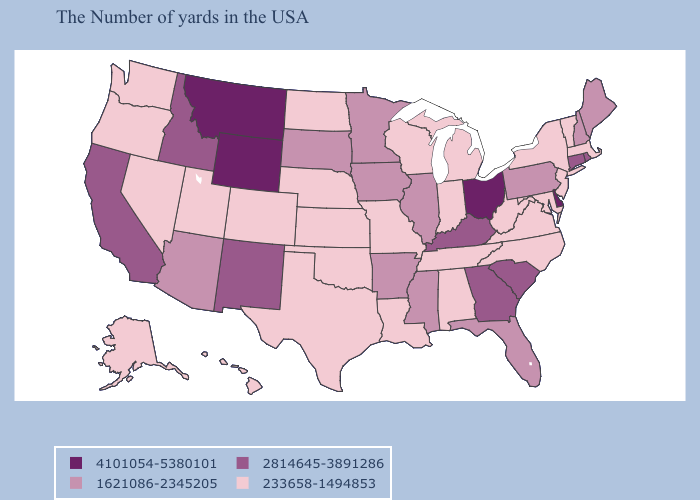Does the map have missing data?
Write a very short answer. No. Does Virginia have the highest value in the South?
Give a very brief answer. No. What is the value of Indiana?
Keep it brief. 233658-1494853. Which states hav the highest value in the Northeast?
Answer briefly. Rhode Island, Connecticut. What is the highest value in the MidWest ?
Be succinct. 4101054-5380101. Name the states that have a value in the range 233658-1494853?
Be succinct. Massachusetts, Vermont, New York, New Jersey, Maryland, Virginia, North Carolina, West Virginia, Michigan, Indiana, Alabama, Tennessee, Wisconsin, Louisiana, Missouri, Kansas, Nebraska, Oklahoma, Texas, North Dakota, Colorado, Utah, Nevada, Washington, Oregon, Alaska, Hawaii. Does the map have missing data?
Short answer required. No. Is the legend a continuous bar?
Answer briefly. No. What is the value of Utah?
Write a very short answer. 233658-1494853. Name the states that have a value in the range 1621086-2345205?
Give a very brief answer. Maine, New Hampshire, Pennsylvania, Florida, Illinois, Mississippi, Arkansas, Minnesota, Iowa, South Dakota, Arizona. Among the states that border Utah , which have the lowest value?
Answer briefly. Colorado, Nevada. Among the states that border Wyoming , which have the lowest value?
Write a very short answer. Nebraska, Colorado, Utah. Among the states that border Wisconsin , does Michigan have the highest value?
Answer briefly. No. Name the states that have a value in the range 1621086-2345205?
Keep it brief. Maine, New Hampshire, Pennsylvania, Florida, Illinois, Mississippi, Arkansas, Minnesota, Iowa, South Dakota, Arizona. What is the value of Vermont?
Keep it brief. 233658-1494853. 